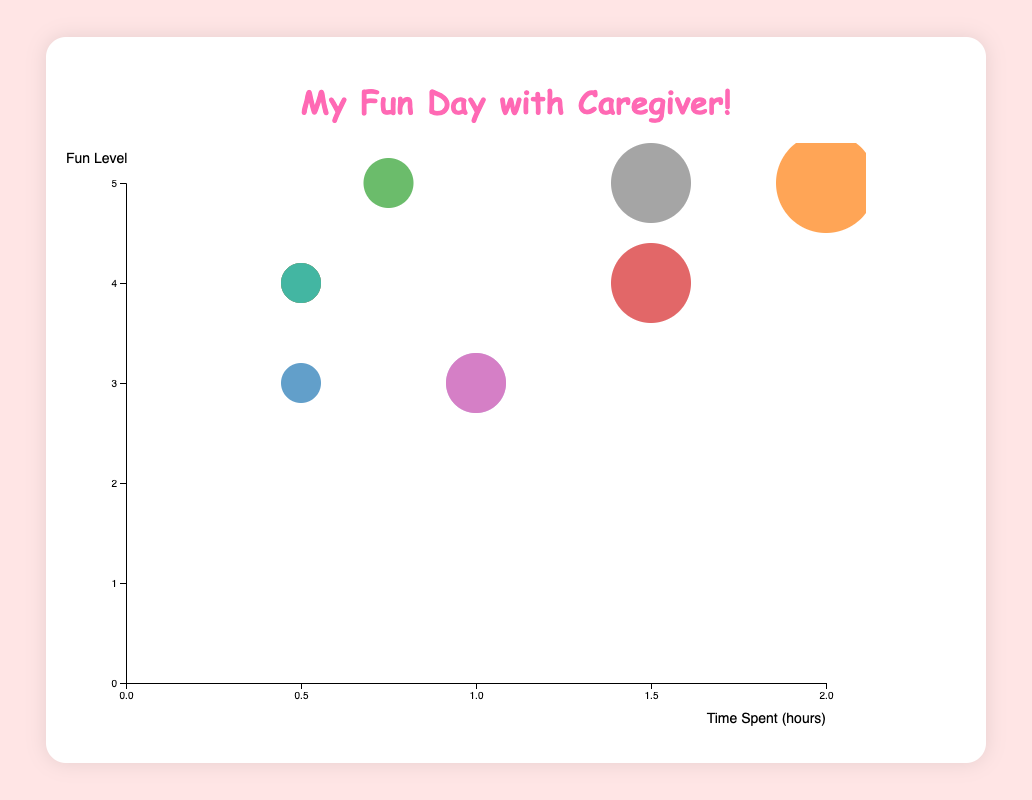What is the title of the figure? The title of the figure is displayed at the top of the chart in large, colorful text.
Answer: My Fun Day with Caregiver! How many activities are shown in the bubble chart? There are 11 circles (bubbles) each representing a different activity on the chart.
Answer: 11 Which activity has the highest fun level and how much time is spent on it? The fun level can be identified by looking at the y-axis values. The activities with a fun level of 5 are "Playtime with Toys", "Storytime", and "Art and Crafts", with the highest time spent being 2.0 hours for "Playtime with Toys".
Answer: Playtime with Toys, 2.0 hours What is the range of time spent on activities? The range can be identified by looking at the x-axis values from the smallest to the largest time spent on activities. The smallest is 0.5 hours and the largest is 2.0 hours.
Answer: 0.5 to 2.0 hours How many activities have a fun level of 4? The fun level can be identified by looking at y-axis values and counting the number of circles at the level of 4. These activities are "Breakfast with Caregiver", "Outdoor Play", "Lunch with Caregiver", "Bath Time", and "Dinner with Caregiver". There are 5 activities in total.
Answer: 5 What is the average fun level of all activities? Calculate the sum of all fun levels and divide by the number of activities. The sum is (4 + 5 + 5 + 4 + 3 + 4 + 3 + 5 + 4 + 4 + 3) = 44 and the number of activities is 11. Therefore, the average fun level is 44/11 = 4.
Answer: 4 Which activities have the same amount of time spent and how fun are they? Identify the activities with the same x-axis (time spent) values. "Breakfast with Caregiver", "Lunch with Caregiver", "Bath Time", and "Dinner with Caregiver" each have 0.5 hours, all with a fun level of 4. "Nap Time" and "TV/Screen Time" both have 1.0 hour, each with a fun level of 3.
Answer: Breakfast with Caregiver, Lunch with Caregiver, Bath Time, Dinner with Caregiver (Fun Level: 4); Nap Time, TV/Screen Time (Fun Level: 3) Which activity is the least fun and how much time is spent on it? The least fun activity can be identified by looking at the y-axis values. The lowest fun level is 3, and activities "Nap Time", "TV/Screen Time", and "Bedtime Routine" each fall into this category. "Nap Time" and "TV/Screen Time" spend 1.0 hour, while "Bedtime Routine" spends 0.5 hours.
Answer: Nap Time, TV/Screen Time, Bedtime Routine; 1.0 hour (Nap Time, TV/Screen Time), 0.5 hours (Bedtime Routine) What is the sum of time spent on all meals with the caregiver? Add the time spent on "Breakfast with Caregiver", "Lunch with Caregiver", and "Dinner with Caregiver". The times are 0.5, 0.5, and 0.5 hours respectively. Therefore, the total time is 0.5 + 0.5 + 0.5 = 1.5 hours.
Answer: 1.5 hours Compare "Art and Crafts" and "Outdoor Play". Which one is more fun and how much time is spent on each? "Art and Crafts" has a fun level of 5 and 1.5 hours spent, while "Outdoor Play" has a fun level of 4 and also 1.5 hours spent. Therefore, "Art and Crafts" is more fun and both activities spend the same amount of time.
Answer: Art and Crafts is more fun, both spend 1.5 hours 